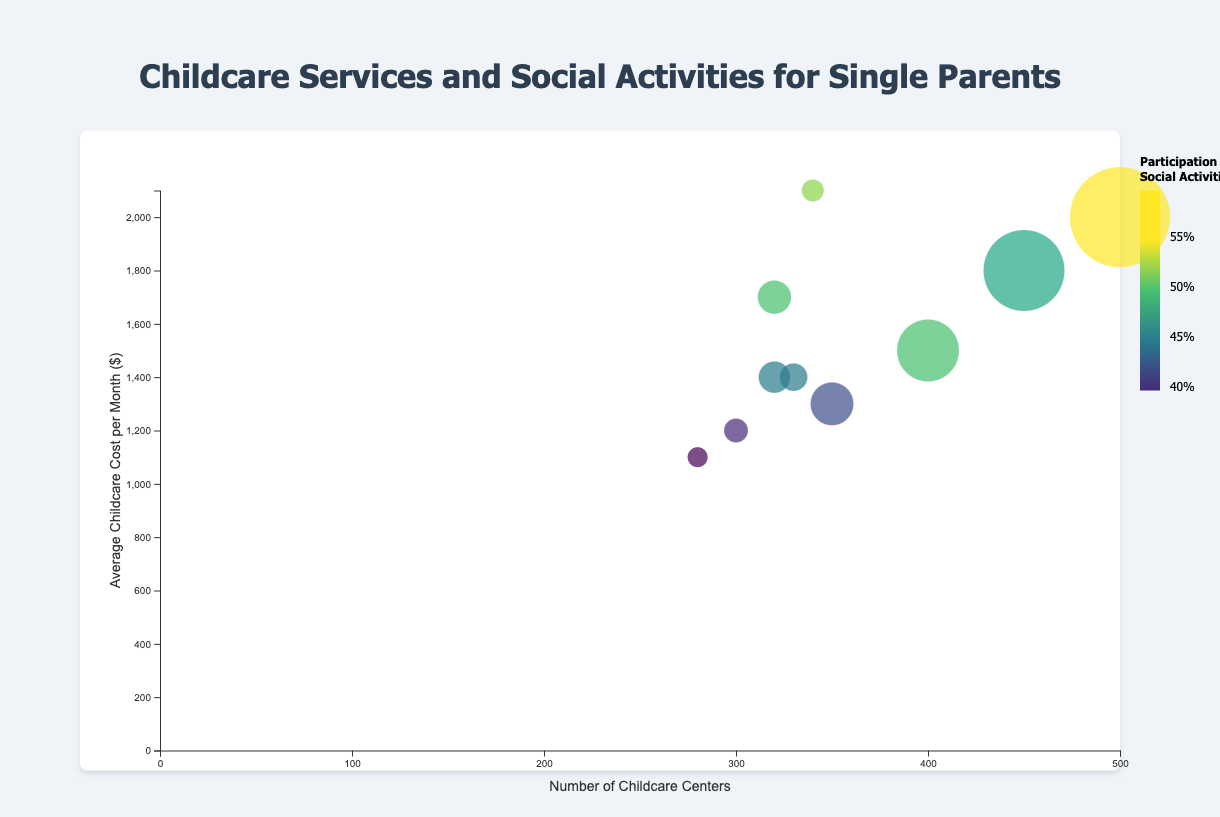What is the average childcare cost per month in New York? Refer to the Y-axis to find the average childcare cost per month for New York, which is plotted as the Y-coordinate of the bubble labeled "New York".
Answer: $2000 How does the number of childcare centers in Los Angeles compare to that in Phoenix? Check the X-axis to find the number of childcare centers for Los Angeles and Phoenix. Los Angeles has 450 centers, and Phoenix has 300 centers, so Los Angeles has more centers.
Answer: Los Angeles has more centers Which city has the highest number of single-parent households? Identify the bubble with the largest radius, as it represents the highest number of single-parent households. In this case, New York has the largest bubble radius.
Answer: New York What is the relationship between average childcare cost and social activities participation rate in San Diego? Look at the Y-coordinates (average childcare cost) and the color gradient (social activities participation rate) for San Diego. San Diego has a high childcare cost at $1700 and a participation rate of 50%.
Answer: High childcare cost and moderate participation rate Which city has the lowest social activities participation rate, and what are its childcare cost and number of centers? Identify the bubble with the darkest color since low participation rates are represented with darker colors. San Antonio has the lowest rate at 38%. The cost is $1100, and the number of childcare centers is 280.
Answer: San Antonio, $1100, 280 centers What is the combined number of single-parent households in Chicago and Philadelphia? Find the number of single-parent households for both cities and add them together: Chicago (200,000) and Philadelphia (120,000). Thus, 200,000 + 120,000 = 320,000.
Answer: 320,000 Is there a city with fewer childcare centers but higher social activities participation compared to San Diego? Compare cities with fewer than 320 childcare centers and check their social activities participation rate. San Jose, with 340 centers and a 52% participation rate, has a higher participation rate but more centers. No other city fits.
Answer: No How do the childcare costs in Houston compare to those in Philadelphia? Find the Y-axis positions of the bubbles for Houston and Philadelphia. Houston's average cost is $1300, and Philadelphia's is $1400. Houston's costs are lower.
Answer: Houston's costs are lower What is the range of the number of childcare centers across all cities? Identify the minimum and maximum values on the X-axis. The minimum is San Antonio with 280 centers, and the maximum is New York with 500 centers. The range is 500 - 280 = 220.
Answer: 220 Which city appears to have a good balance between childcare cost, availability, and social activities participation? Analyze the bubbles positioned between medium childcare cost (Y-axis), a higher number of childcare centers (X-axis), and moderate participation (color). Chicago, with decent childcare cost ($1500), many centers (400), and 50% participation, seems balanced.
Answer: Chicago 